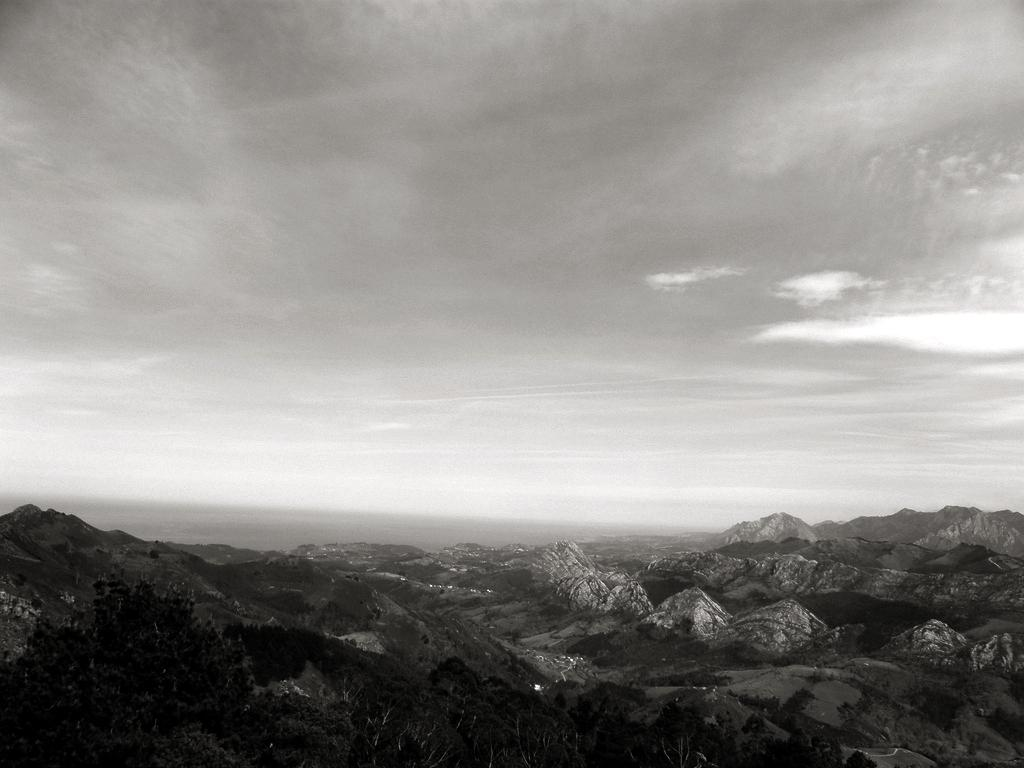What type of natural formation can be seen in the image? There are mountains in the image. What is visible at the top of the image? The sky is visible at the top of the image. What language is spoken by the mountains in the image? Mountains do not speak any language, as they are inanimate objects. 